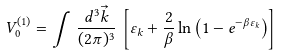<formula> <loc_0><loc_0><loc_500><loc_500>V _ { 0 } ^ { ( 1 ) } = \int \, { \frac { d ^ { 3 } \vec { k } } { ( 2 \pi ) ^ { 3 } } } \, \left [ \varepsilon _ { k } + \frac { 2 } { \beta } \ln \left ( 1 - e ^ { - \beta \varepsilon _ { k } } \right ) \right ]</formula> 